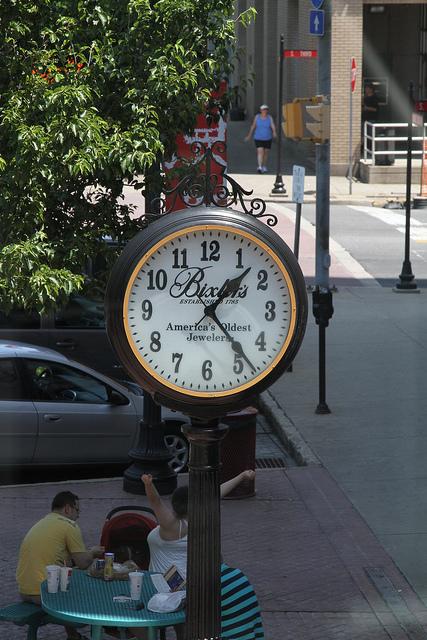What is the woman in white doing?
Short answer required. Stretching. How many wheels?
Keep it brief. 1. Is this clock in English?
Answer briefly. Yes. How many clocks are posted?
Give a very brief answer. 1. What time is it?
Be succinct. 1:24. What time is displayed on the clock?
Quick response, please. 1:24. Where is the clock?
Concise answer only. Outside. Who made the cock?
Give a very brief answer. Bixler's. 